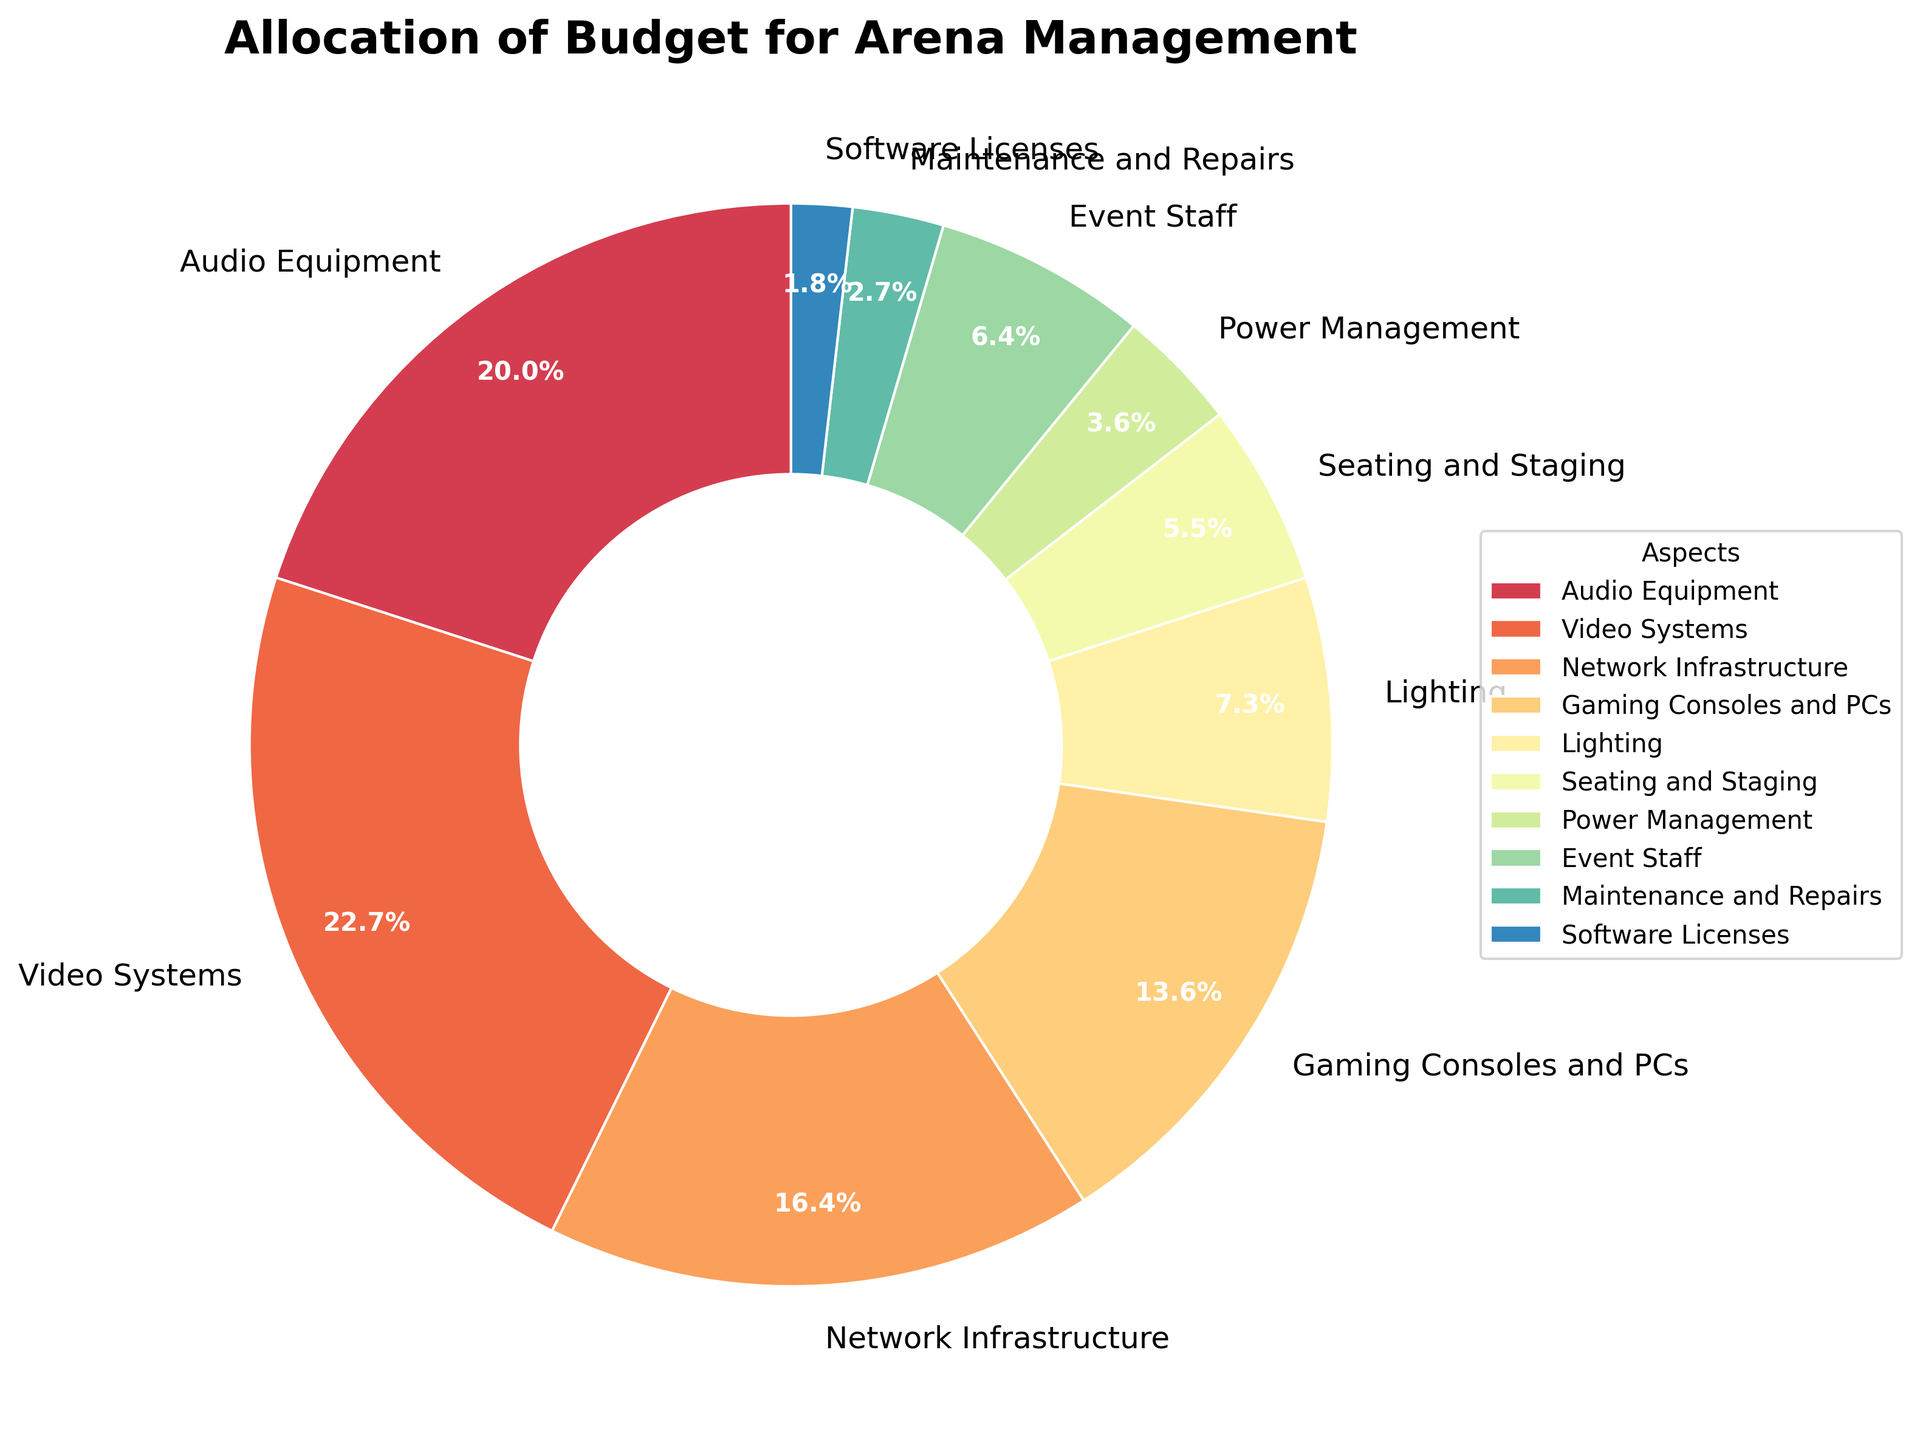What is the percentage allocation for Audio Equipment? Locate the section labeled "Audio Equipment" on the pie chart and read the percentage value next to it.
Answer: 22% Which aspect has the highest budget allocation, and what is its percentage? Find the section of the pie chart with the largest area. The label next to this section indicates the aspect and its percentage.
Answer: Video Systems, 25% What is the difference in budget allocation between Gaming Consoles and PCs and Event Staff? Locate the percentages for "Gaming Consoles and PCs" and "Event Staff." Subtract the smaller percentage from the larger one: 15% - 7% = 8%.
Answer: 8% What is the combined budget allocation for Seating and Staging, Power Management, and Maintenance and Repairs? Add the percentages for "Seating and Staging" (6%), "Power Management" (4%), and "Maintenance and Repairs" (3%). The sum is 6% + 4% + 3% = 13%.
Answer: 13% Which aspect has a smaller budget allocation: Lighting or Network Infrastructure? Compare the percentages for "Lighting" (8%) and "Network Infrastructure" (18%) from the pie chart and identify the one with the smaller value.
Answer: Lighting How much more budget does Video Systems receive compared to Software Licenses? Subtract the percentage for "Software Licenses" (2%) from "Video Systems" (25%): 25% - 2% = 23%.
Answer: 23% What is the total percentage allocation for aspects with budgets less than 10%? Identify the aspects with percentages less than 10%: Lighting (8%), Seating and Staging (6%), Power Management (4%), Event Staff (7%), Maintenance and Repairs (3%), Software Licenses (2%). Add these percentages: 8% + 6% + 4% + 7% + 3% + 2% = 30%.
Answer: 30% Which section is labeled with the darkest color, and what percentage does it represent? The pie chart uses a color gradient. The darkest color typically represents the highest percentage. Identify that section, refer to its label, and read its percentage.
Answer: Video Systems, 25% What is the average budget allocation for Lighting and Event Staff combined? Add the percentages for "Lighting" (8%) and "Event Staff" (7%) together, then divide by 2: (8% + 7%) / 2 = 7.5%.
Answer: 7.5% 如果减去音频设备和视频系统的预算后，剩余的百分比是多少？ 将 “音频设备”（22%） 和 “视频系统”（25%）的百分比分别相加，然后用总的 100% 减去这个和。计算：100% - (22% + 25%) = 100% - 47% = 53%。
Answer: 53% 